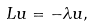<formula> <loc_0><loc_0><loc_500><loc_500>L u = - \lambda u ,</formula> 